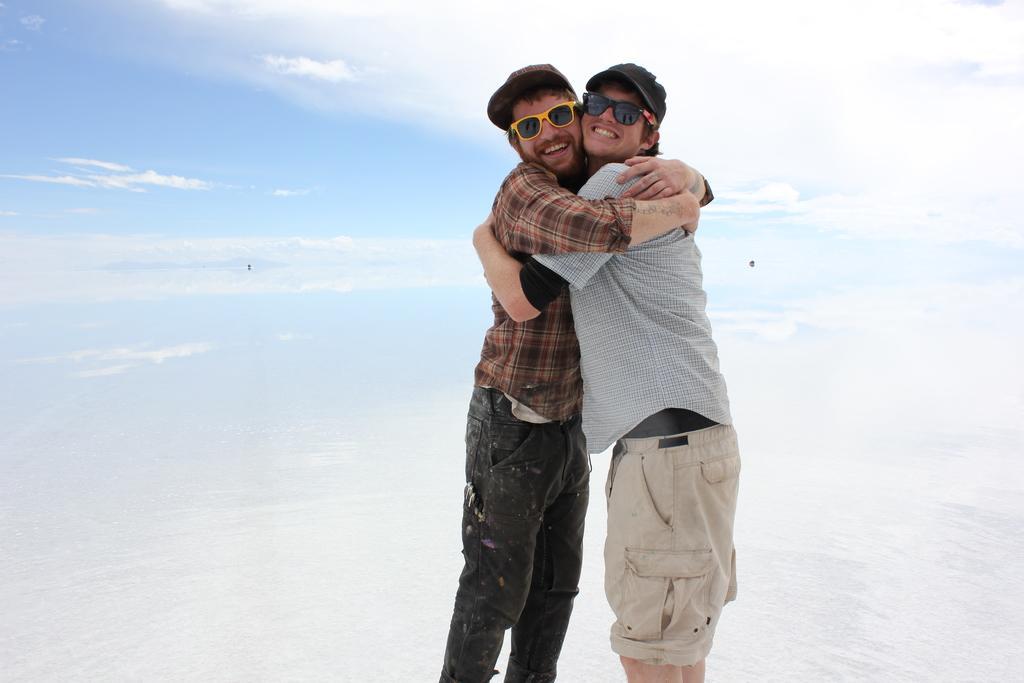In one or two sentences, can you explain what this image depicts? Here in this picture we can see two men standing over a place and hugging with each other and both of them are smiling and wearing caps and goggles on them over there and we can see clouds in the sky over there. 